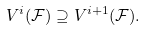<formula> <loc_0><loc_0><loc_500><loc_500>V ^ { i } ( \mathcal { F } ) \supseteq V ^ { i + 1 } ( \mathcal { F } ) .</formula> 